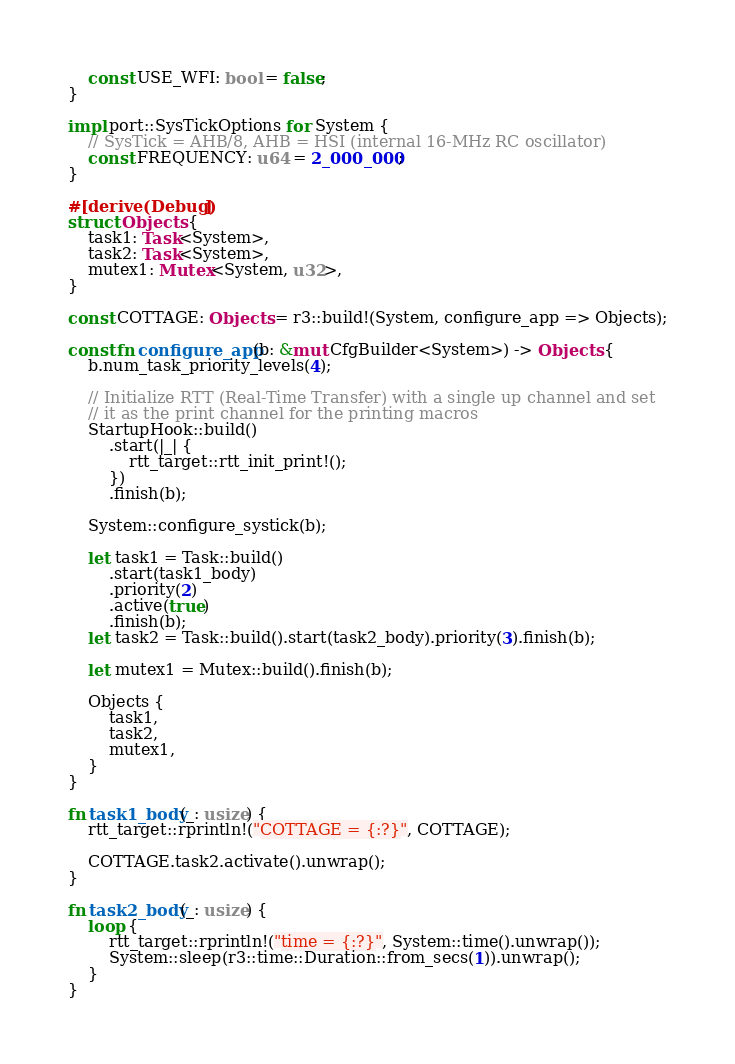<code> <loc_0><loc_0><loc_500><loc_500><_Rust_>    const USE_WFI: bool = false;
}

impl port::SysTickOptions for System {
    // SysTick = AHB/8, AHB = HSI (internal 16-MHz RC oscillator)
    const FREQUENCY: u64 = 2_000_000;
}

#[derive(Debug)]
struct Objects {
    task1: Task<System>,
    task2: Task<System>,
    mutex1: Mutex<System, u32>,
}

const COTTAGE: Objects = r3::build!(System, configure_app => Objects);

const fn configure_app(b: &mut CfgBuilder<System>) -> Objects {
    b.num_task_priority_levels(4);

    // Initialize RTT (Real-Time Transfer) with a single up channel and set
    // it as the print channel for the printing macros
    StartupHook::build()
        .start(|_| {
            rtt_target::rtt_init_print!();
        })
        .finish(b);

    System::configure_systick(b);

    let task1 = Task::build()
        .start(task1_body)
        .priority(2)
        .active(true)
        .finish(b);
    let task2 = Task::build().start(task2_body).priority(3).finish(b);

    let mutex1 = Mutex::build().finish(b);

    Objects {
        task1,
        task2,
        mutex1,
    }
}

fn task1_body(_: usize) {
    rtt_target::rprintln!("COTTAGE = {:?}", COTTAGE);

    COTTAGE.task2.activate().unwrap();
}

fn task2_body(_: usize) {
    loop {
        rtt_target::rprintln!("time = {:?}", System::time().unwrap());
        System::sleep(r3::time::Duration::from_secs(1)).unwrap();
    }
}
</code> 